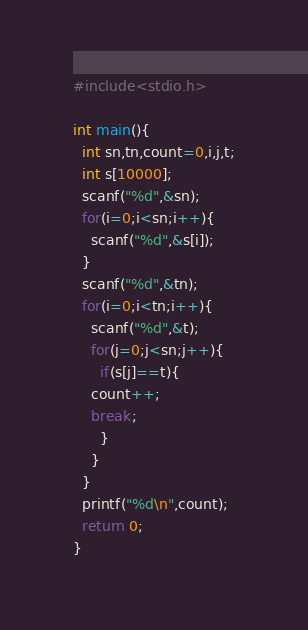Convert code to text. <code><loc_0><loc_0><loc_500><loc_500><_C_>#include<stdio.h>

int main(){
  int sn,tn,count=0,i,j,t;
  int s[10000];
  scanf("%d",&sn);
  for(i=0;i<sn;i++){
    scanf("%d",&s[i]);
  }
  scanf("%d",&tn);
  for(i=0;i<tn;i++){
    scanf("%d",&t);
    for(j=0;j<sn;j++){
      if(s[j]==t){
	count++;
	break;
      }
    }
  }
  printf("%d\n",count);
  return 0;
}</code> 